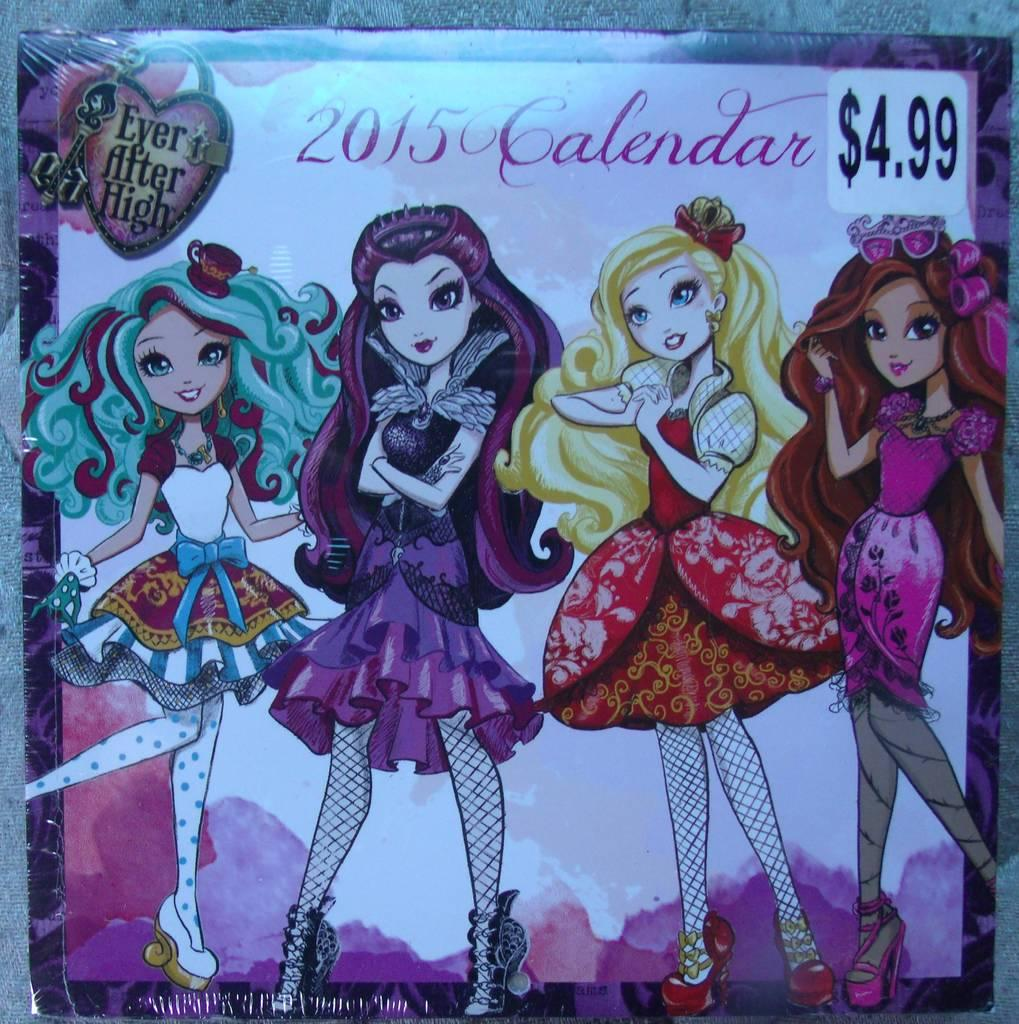What type of object is depicted in the image? The object is a box. Can you describe the condition of the box? The box is sealed. What visual elements are present on the box? There are cartoon images of four girls standing on the box, as well as letters and numbers. What type of action is the box performing in the image? The box is not performing any action in the image; it is a static object. What religious symbolism can be found on the box? There is no religious symbolism present on the box. 